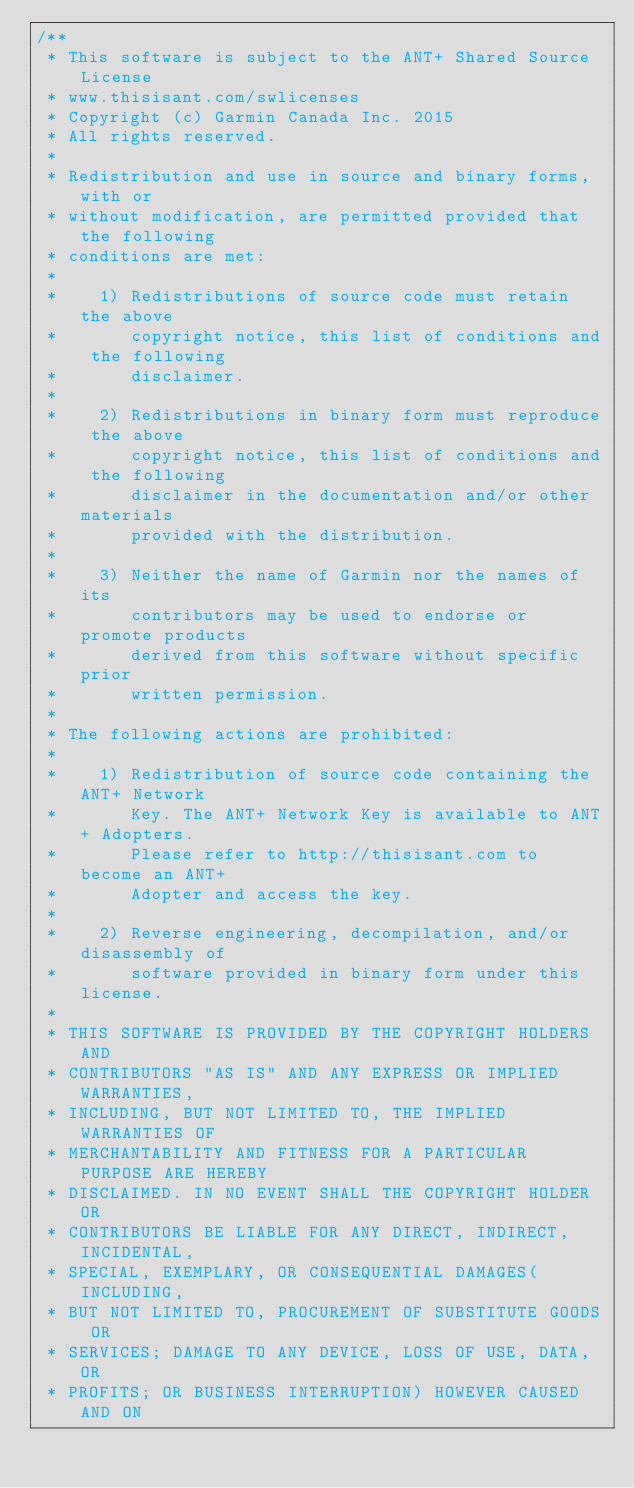Convert code to text. <code><loc_0><loc_0><loc_500><loc_500><_C_>/**
 * This software is subject to the ANT+ Shared Source License
 * www.thisisant.com/swlicenses
 * Copyright (c) Garmin Canada Inc. 2015
 * All rights reserved.
 *
 * Redistribution and use in source and binary forms, with or
 * without modification, are permitted provided that the following
 * conditions are met:
 *
 *    1) Redistributions of source code must retain the above
 *       copyright notice, this list of conditions and the following
 *       disclaimer.
 *
 *    2) Redistributions in binary form must reproduce the above
 *       copyright notice, this list of conditions and the following
 *       disclaimer in the documentation and/or other materials
 *       provided with the distribution.
 *
 *    3) Neither the name of Garmin nor the names of its
 *       contributors may be used to endorse or promote products
 *       derived from this software without specific prior
 *       written permission.
 *
 * The following actions are prohibited:
 *
 *    1) Redistribution of source code containing the ANT+ Network
 *       Key. The ANT+ Network Key is available to ANT+ Adopters.
 *       Please refer to http://thisisant.com to become an ANT+
 *       Adopter and access the key. 
 *
 *    2) Reverse engineering, decompilation, and/or disassembly of
 *       software provided in binary form under this license.
 *
 * THIS SOFTWARE IS PROVIDED BY THE COPYRIGHT HOLDERS AND
 * CONTRIBUTORS "AS IS" AND ANY EXPRESS OR IMPLIED WARRANTIES,
 * INCLUDING, BUT NOT LIMITED TO, THE IMPLIED WARRANTIES OF
 * MERCHANTABILITY AND FITNESS FOR A PARTICULAR PURPOSE ARE HEREBY
 * DISCLAIMED. IN NO EVENT SHALL THE COPYRIGHT HOLDER OR
 * CONTRIBUTORS BE LIABLE FOR ANY DIRECT, INDIRECT, INCIDENTAL,
 * SPECIAL, EXEMPLARY, OR CONSEQUENTIAL DAMAGES(INCLUDING, 
 * BUT NOT LIMITED TO, PROCUREMENT OF SUBSTITUTE GOODS OR 
 * SERVICES; DAMAGE TO ANY DEVICE, LOSS OF USE, DATA, OR 
 * PROFITS; OR BUSINESS INTERRUPTION) HOWEVER CAUSED AND ON</code> 